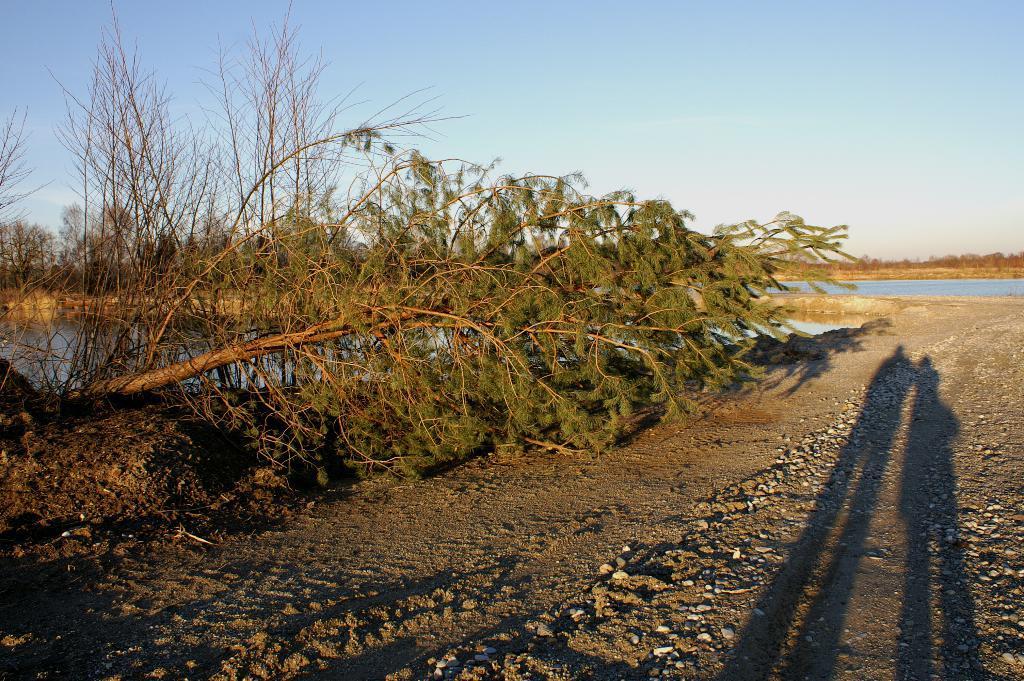How would you summarize this image in a sentence or two? In this picture I can see some trees and water pond. 